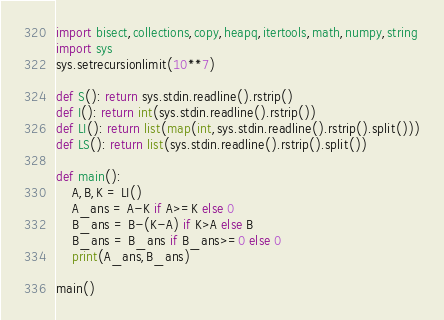Convert code to text. <code><loc_0><loc_0><loc_500><loc_500><_Python_>import bisect,collections,copy,heapq,itertools,math,numpy,string
import sys
sys.setrecursionlimit(10**7)

def S(): return sys.stdin.readline().rstrip()
def I(): return int(sys.stdin.readline().rstrip())
def LI(): return list(map(int,sys.stdin.readline().rstrip().split()))
def LS(): return list(sys.stdin.readline().rstrip().split())

def main():
    A,B,K = LI()
    A_ans = A-K if A>=K else 0
    B_ans = B-(K-A) if K>A else B
    B_ans = B_ans if B_ans>=0 else 0
    print(A_ans,B_ans)

main()

</code> 